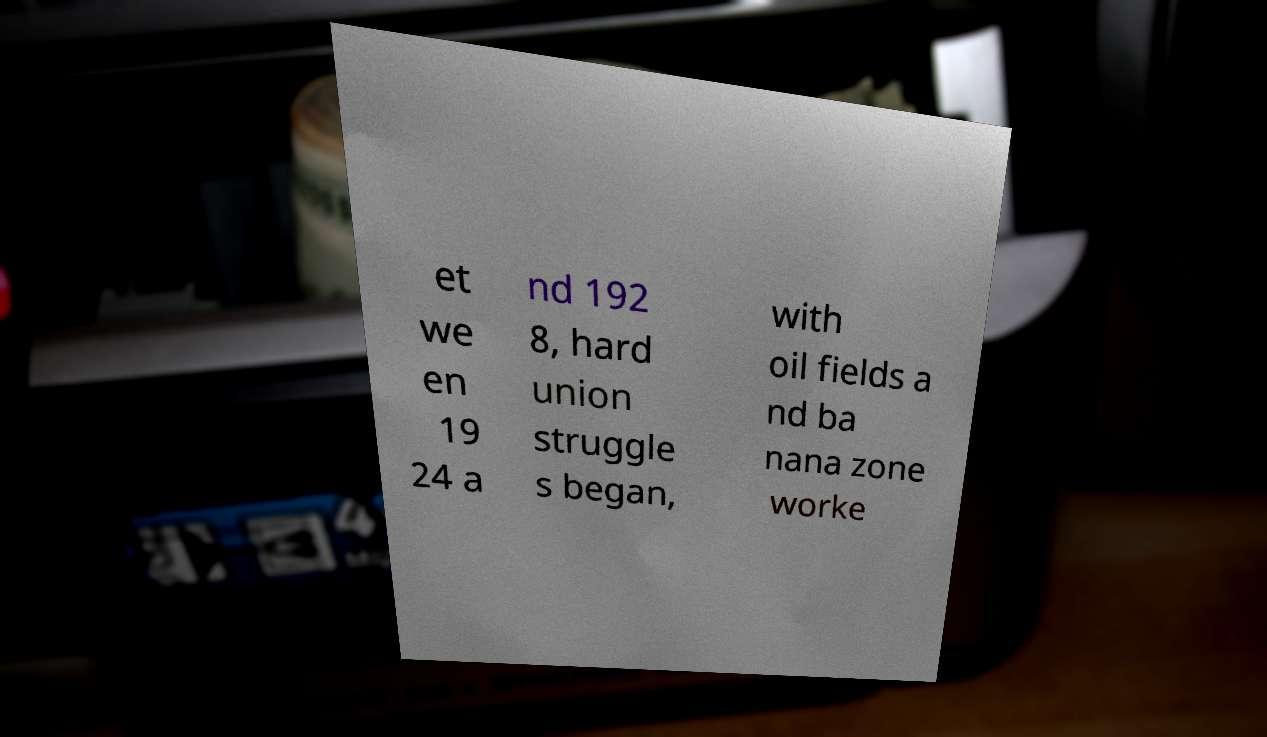Can you read and provide the text displayed in the image?This photo seems to have some interesting text. Can you extract and type it out for me? et we en 19 24 a nd 192 8, hard union struggle s began, with oil fields a nd ba nana zone worke 